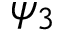Convert formula to latex. <formula><loc_0><loc_0><loc_500><loc_500>\psi _ { 3 } \,</formula> 